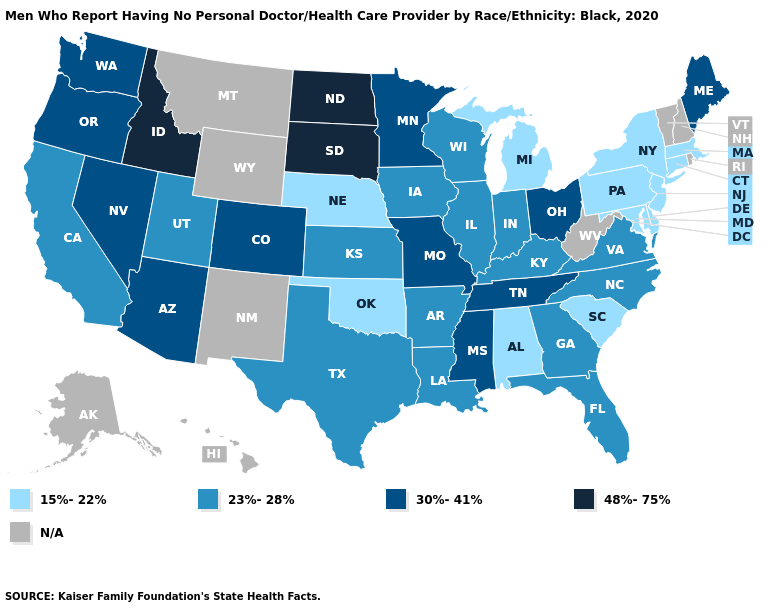Name the states that have a value in the range 30%-41%?
Quick response, please. Arizona, Colorado, Maine, Minnesota, Mississippi, Missouri, Nevada, Ohio, Oregon, Tennessee, Washington. Does the map have missing data?
Quick response, please. Yes. What is the value of Michigan?
Be succinct. 15%-22%. Is the legend a continuous bar?
Quick response, please. No. Name the states that have a value in the range 23%-28%?
Be succinct. Arkansas, California, Florida, Georgia, Illinois, Indiana, Iowa, Kansas, Kentucky, Louisiana, North Carolina, Texas, Utah, Virginia, Wisconsin. What is the value of Mississippi?
Quick response, please. 30%-41%. Does the map have missing data?
Short answer required. Yes. What is the lowest value in the West?
Keep it brief. 23%-28%. Name the states that have a value in the range 23%-28%?
Answer briefly. Arkansas, California, Florida, Georgia, Illinois, Indiana, Iowa, Kansas, Kentucky, Louisiana, North Carolina, Texas, Utah, Virginia, Wisconsin. Which states have the lowest value in the USA?
Write a very short answer. Alabama, Connecticut, Delaware, Maryland, Massachusetts, Michigan, Nebraska, New Jersey, New York, Oklahoma, Pennsylvania, South Carolina. Which states hav the highest value in the South?
Concise answer only. Mississippi, Tennessee. Among the states that border Virginia , which have the highest value?
Give a very brief answer. Tennessee. Does Oklahoma have the lowest value in the South?
Keep it brief. Yes. 